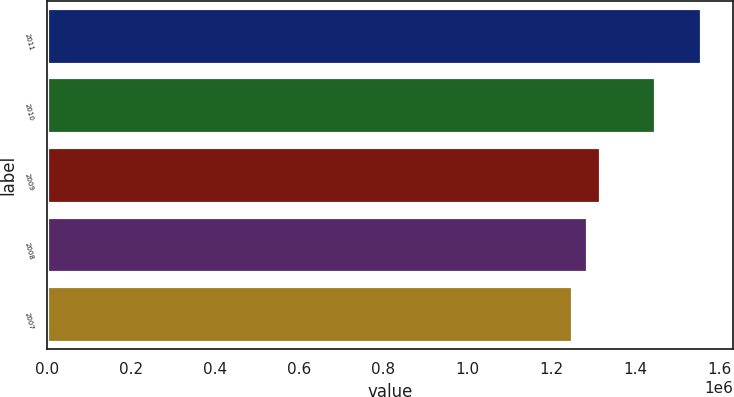Convert chart. <chart><loc_0><loc_0><loc_500><loc_500><bar_chart><fcel>2011<fcel>2010<fcel>2009<fcel>2008<fcel>2007<nl><fcel>1.556e+06<fcel>1.448e+06<fcel>1.3166e+06<fcel>1.286e+06<fcel>1.25e+06<nl></chart> 